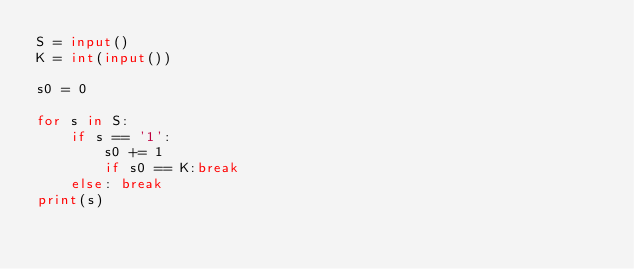Convert code to text. <code><loc_0><loc_0><loc_500><loc_500><_Python_>S = input()
K = int(input())

s0 = 0

for s in S:
    if s == '1':
        s0 += 1
        if s0 == K:break
    else: break
print(s)</code> 